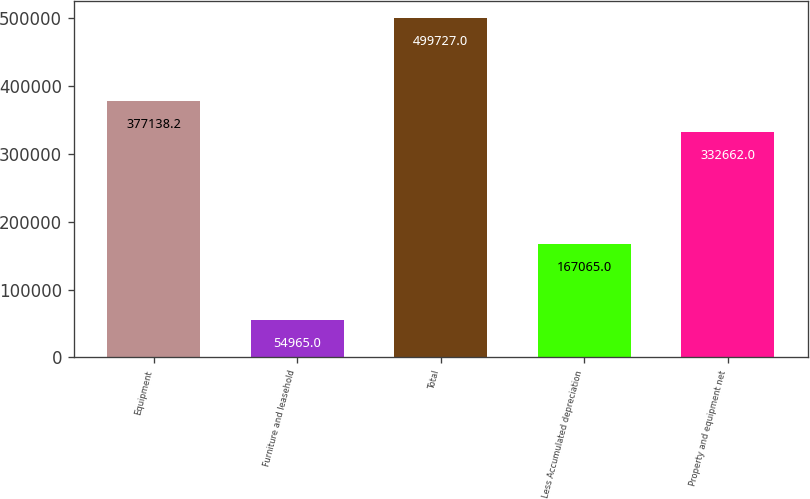Convert chart. <chart><loc_0><loc_0><loc_500><loc_500><bar_chart><fcel>Equipment<fcel>Furniture and leasehold<fcel>Total<fcel>Less Accumulated depreciation<fcel>Property and equipment net<nl><fcel>377138<fcel>54965<fcel>499727<fcel>167065<fcel>332662<nl></chart> 